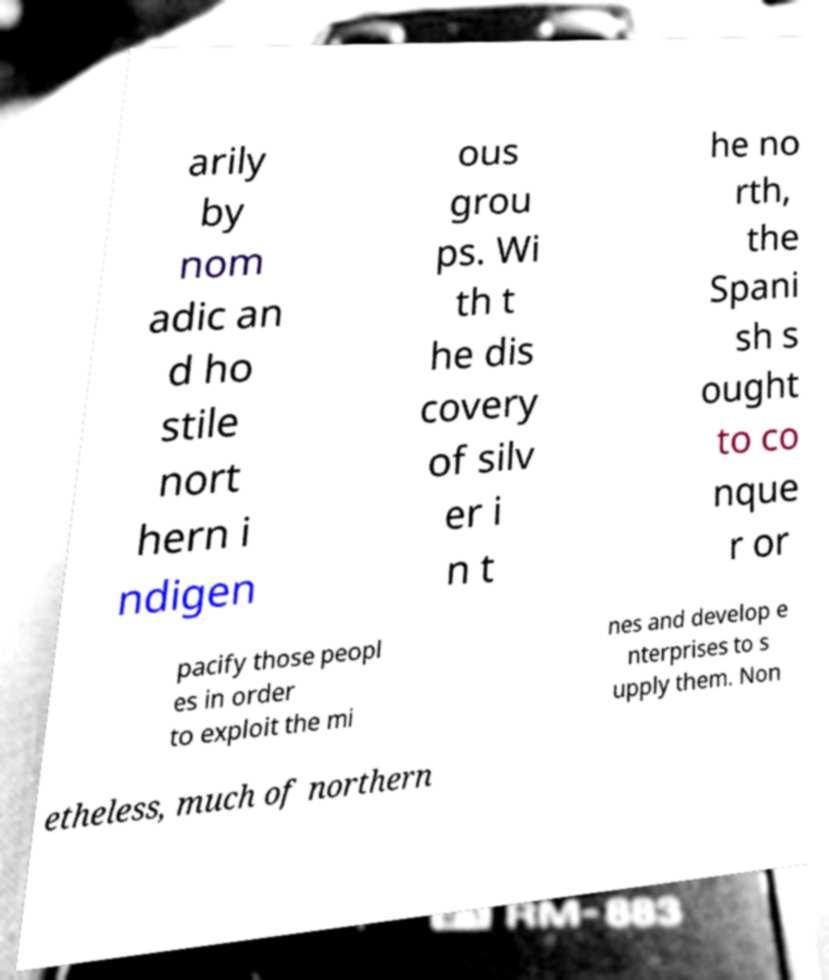There's text embedded in this image that I need extracted. Can you transcribe it verbatim? arily by nom adic an d ho stile nort hern i ndigen ous grou ps. Wi th t he dis covery of silv er i n t he no rth, the Spani sh s ought to co nque r or pacify those peopl es in order to exploit the mi nes and develop e nterprises to s upply them. Non etheless, much of northern 